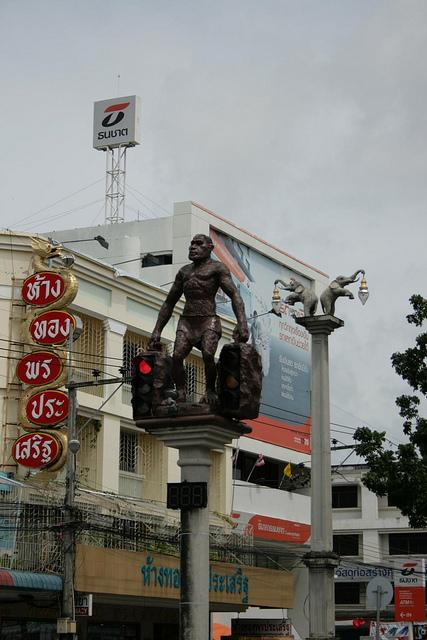What is the man in the statue carrying?
Be succinct. Luggage. What language is written?
Write a very short answer. Arabic. Can you read what is written on the red signs?
Answer briefly. No. 